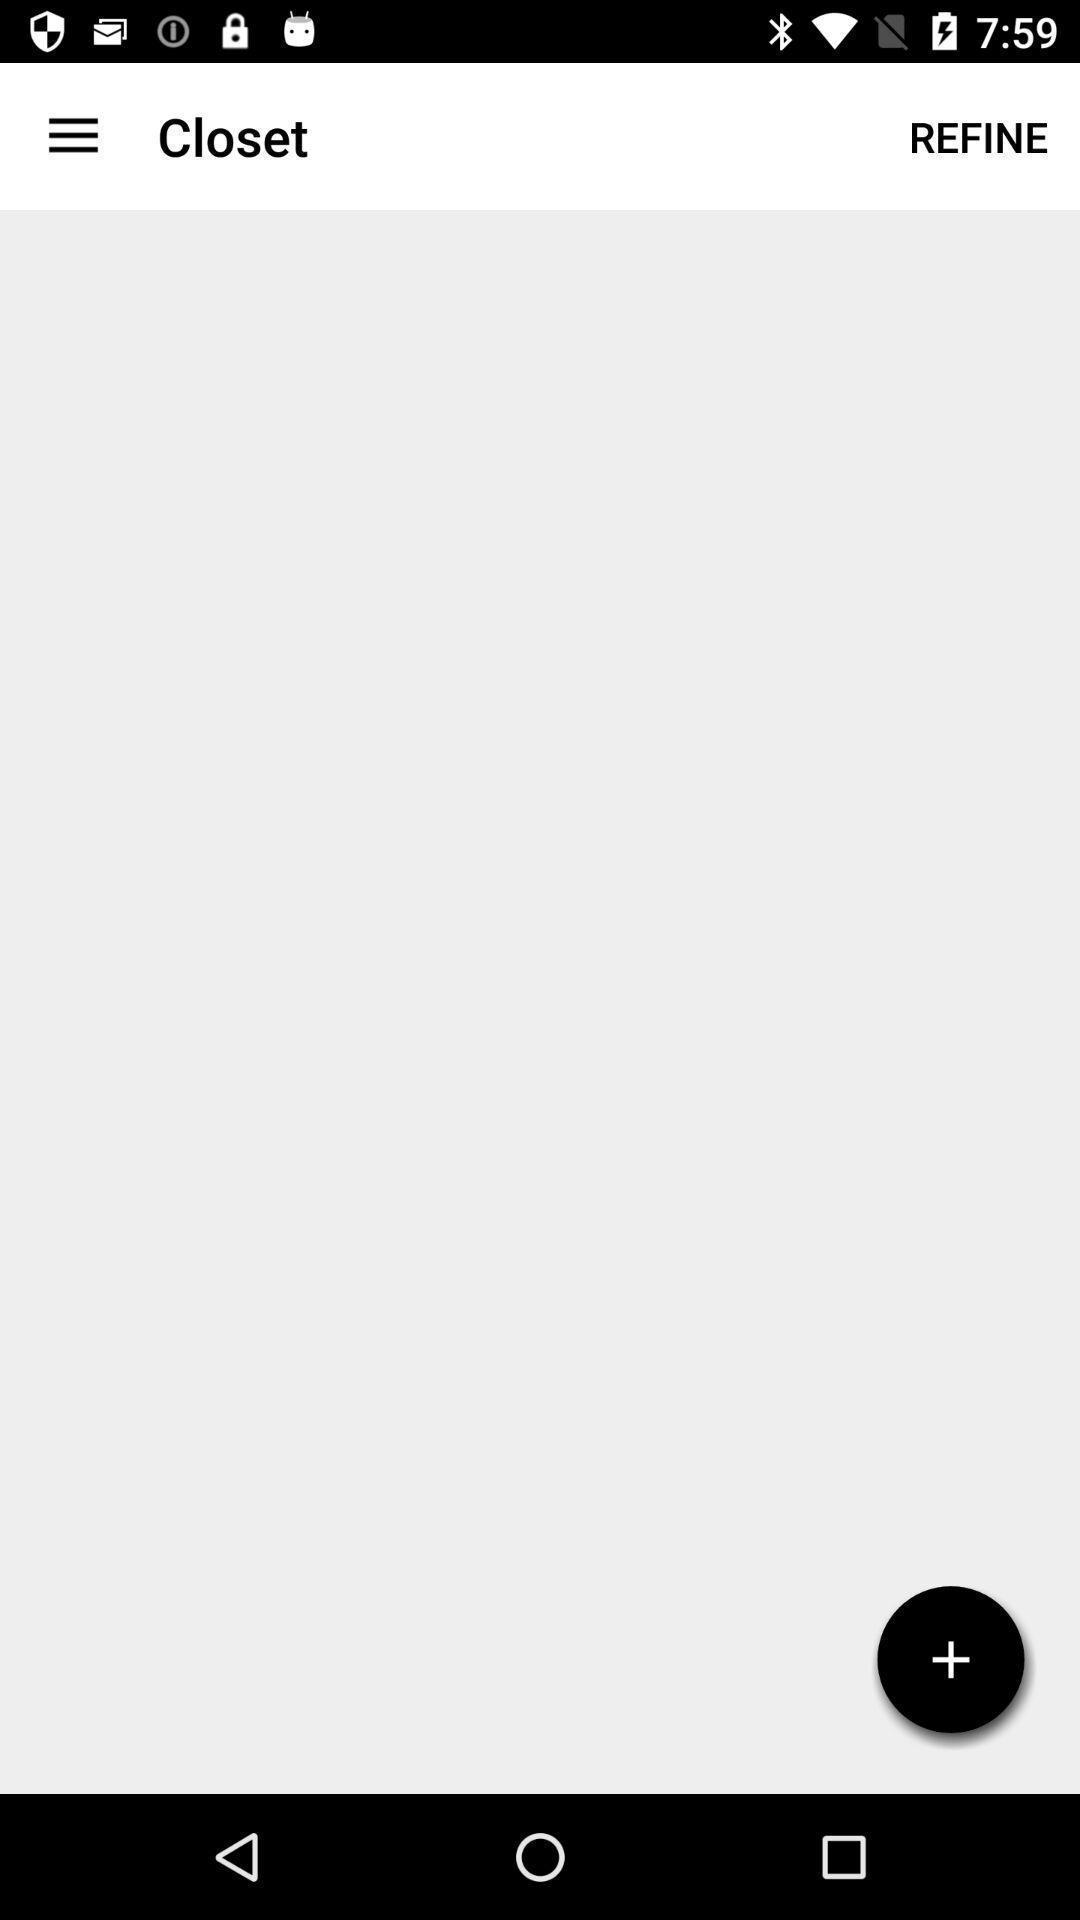Summarize the main components in this picture. Screen showing page with add option. 